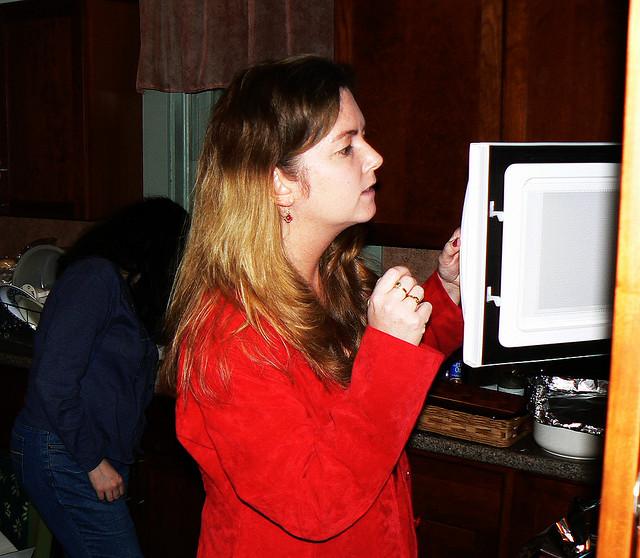What appliance is she standing next to?
Quick response, please. Microwave. What color is her shirt?
Quick response, please. Red. What color is the woman wearing?
Be succinct. Red. Is slenderman sneaking up behind this woman?
Give a very brief answer. No. Where is this woman's lunch?
Be succinct. Microwave. 